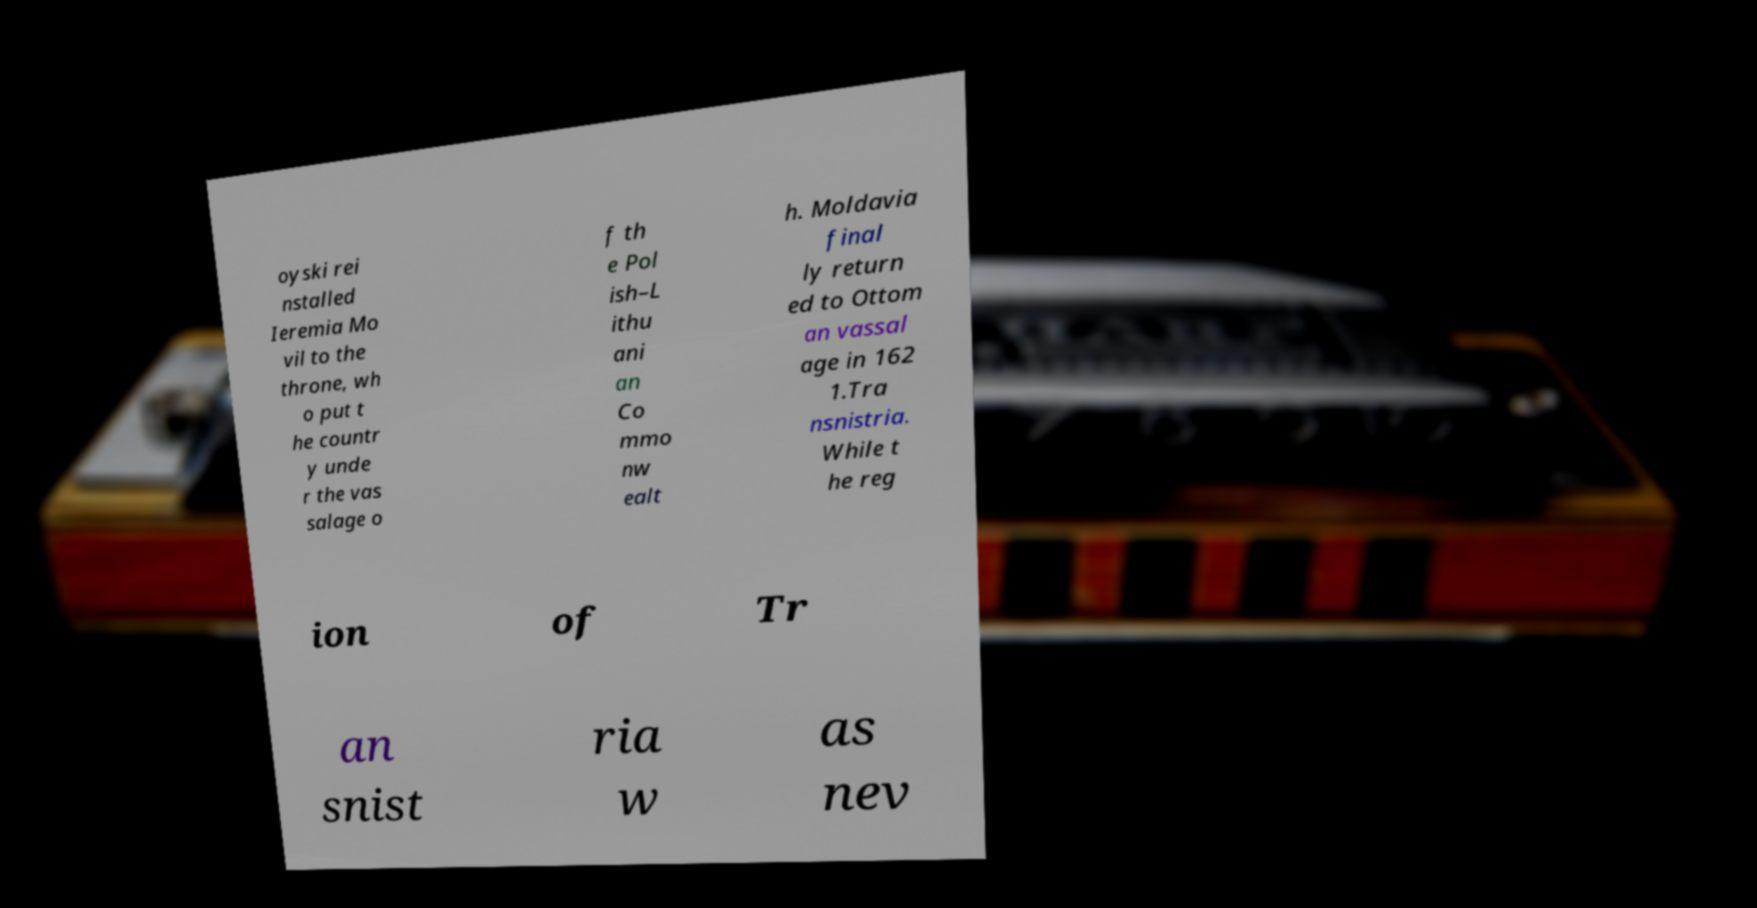There's text embedded in this image that I need extracted. Can you transcribe it verbatim? oyski rei nstalled Ieremia Mo vil to the throne, wh o put t he countr y unde r the vas salage o f th e Pol ish–L ithu ani an Co mmo nw ealt h. Moldavia final ly return ed to Ottom an vassal age in 162 1.Tra nsnistria. While t he reg ion of Tr an snist ria w as nev 